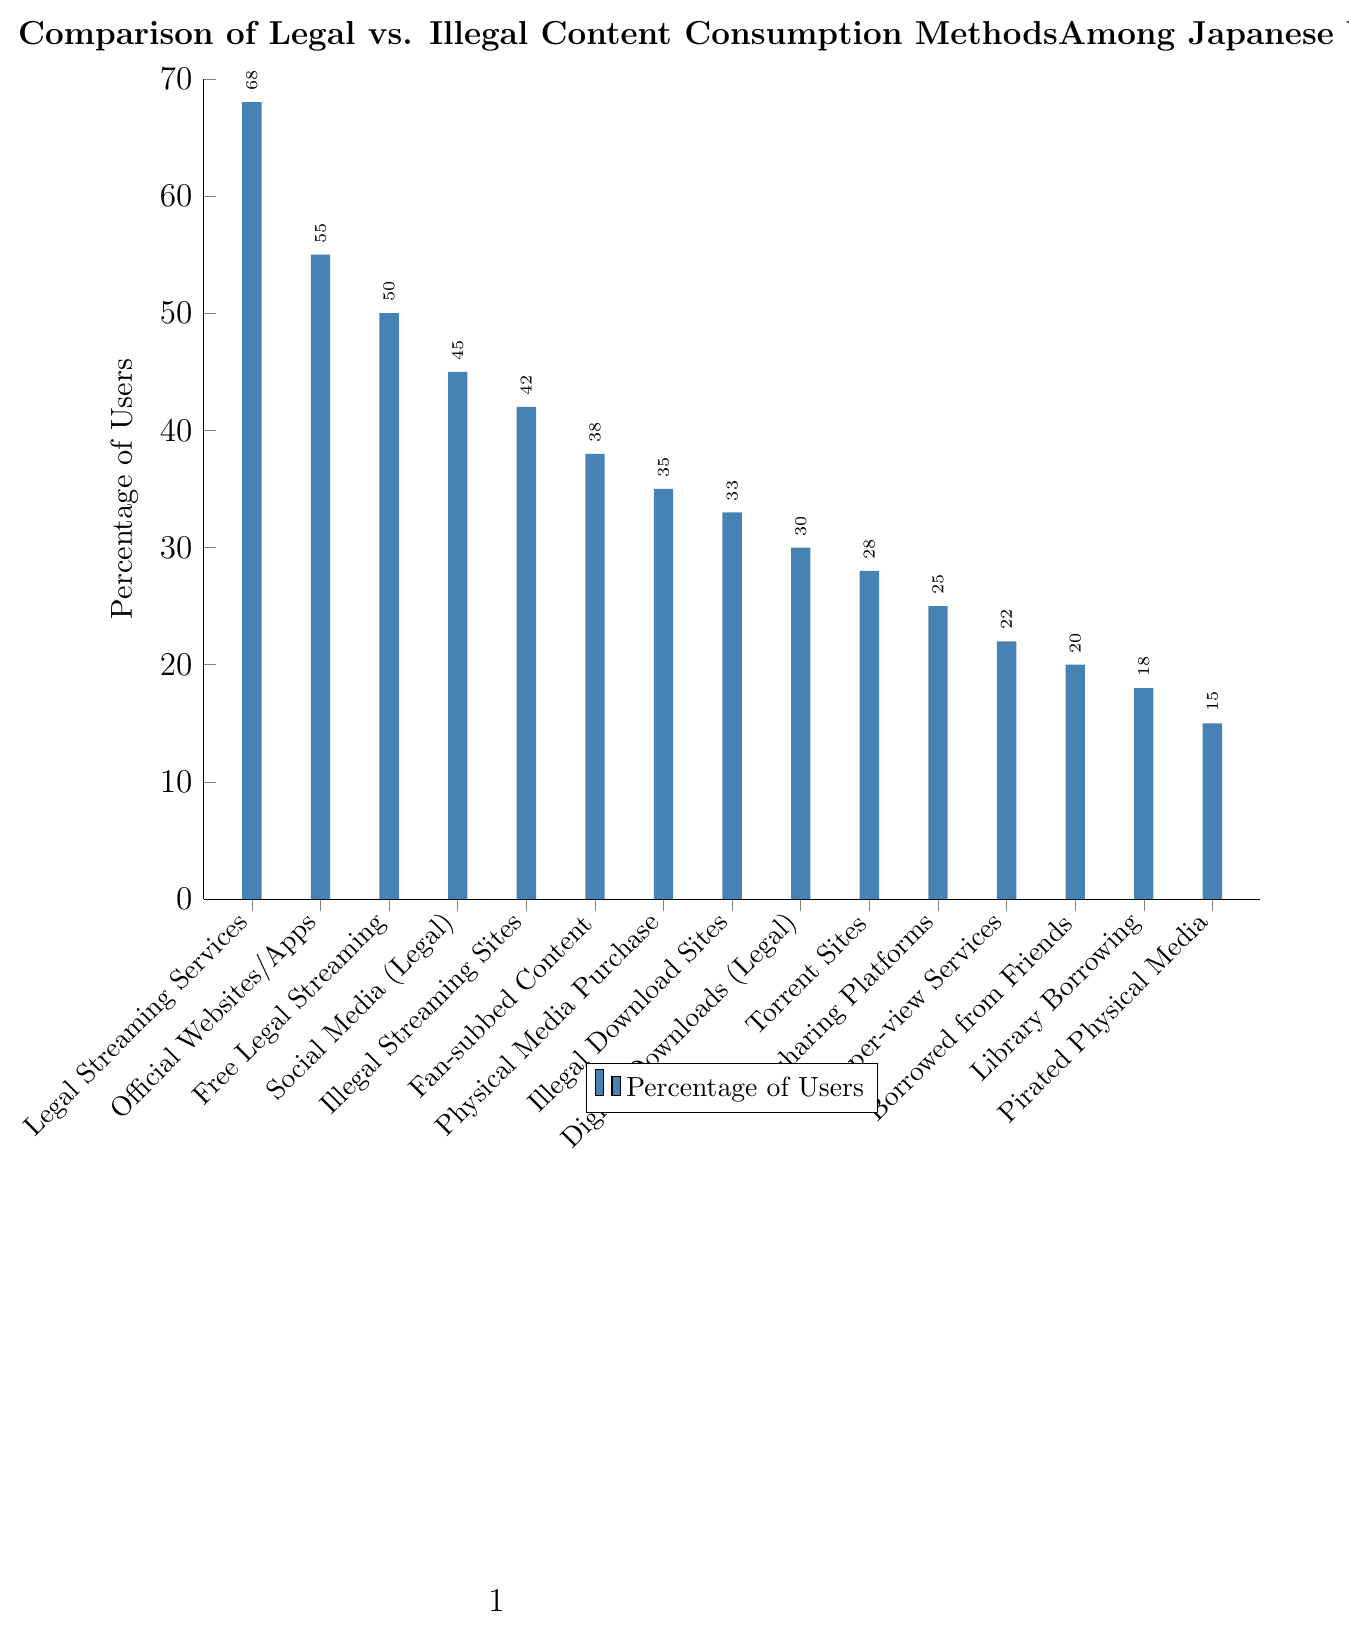Which content consumption method has the highest percentage of users? The bar labeled "Legal Streaming Services" is the tallest and reaches 68%, which is higher than any other bar in the chart.
Answer: Legal Streaming Services How does the percentage of users for "Illegal Streaming Sites" compare to "Torrent Sites"? The bar for "Illegal Streaming Sites" is taller at 42%, while the "Torrent Sites" bar reaches 28%. Thus, the percentage for "Illegal Streaming Sites" is higher.
Answer: Illegal Streaming Sites What is the combined percentage of users for "Official Websites/Apps" and "Free Legal Streaming (Ad-supported)"? Add the percentages for "Official Websites/Apps" (55%) and "Free Legal Streaming (Ad-supported)" (50%). So, 55 + 50 = 105%.
Answer: 105% Which method has a higher percentage of users, "Physical Media Purchase" or "Digital Downloads (Legal)"? The bar for "Physical Media Purchase" is taller at 35%, compared to "Digital Downloads (Legal)" at 30%. Thus, "Physical Media Purchase" has a higher percentage.
Answer: Physical Media Purchase What is the median percentage value among the listed content consumption methods? Arrange the percentages in ascending order: 15, 18, 20, 22, 25, 28, 30, 33, 35, 38, 42, 45, 50, 55, 68. The middle value (8th in an ordered list of 15 numbers) is 33.
Answer: 33% What is the percentage difference between "Legal Streaming Services" and the least popular method? Identify that "Pirated Physical Media" is the least popular at 15%. Subtract this from "Legal Streaming Services" (68%): 68 - 15 = 53%.
Answer: 53% Which content consumption method has a similar percentage of users to "Social Media Platforms (Legal Content)"? "Social Media Platforms (Legal Content)" has 45%. The closest percentages are "Illegal Streaming Sites" at 42% and "Fan-subbed Content" at 38%. Since 42% is closest, "Illegal Streaming Sites" is similar.
Answer: Illegal Streaming Sites How do "Borrowed from Friends/Family" and "Library Borrowing" percentages compare? The bar for "Borrowed from Friends/Family" reaches 20%, while "Library Borrowing" is at 18%. Therefore, "Borrowed from Friends/Family" has a higher percentage.
Answer: Borrowed from Friends/Family What is the average percentage of users for "Illegal Streaming Sites", "Torrent Sites", and "Fan-subbed Content"? Add the percentages: 42 + 28 + 38 = 108%. Divide by the number of methods (3): 108 / 3 = 36%.
Answer: 36% Is the percentage of users for "Pay-per-view Services" more or less than half the percentage of "Legal Streaming Services"? "Legal Streaming Services" is at 68%. Half of this is 68 / 2 = 34%. "Pay-per-view Services" is at 22%, which is less than 34%.
Answer: Less 